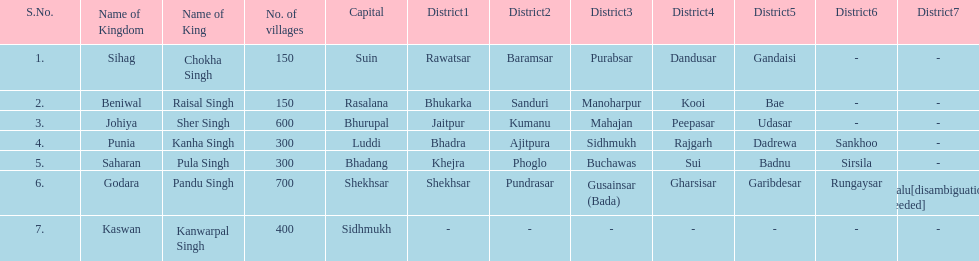What is the next kingdom listed after sihag? Beniwal. 